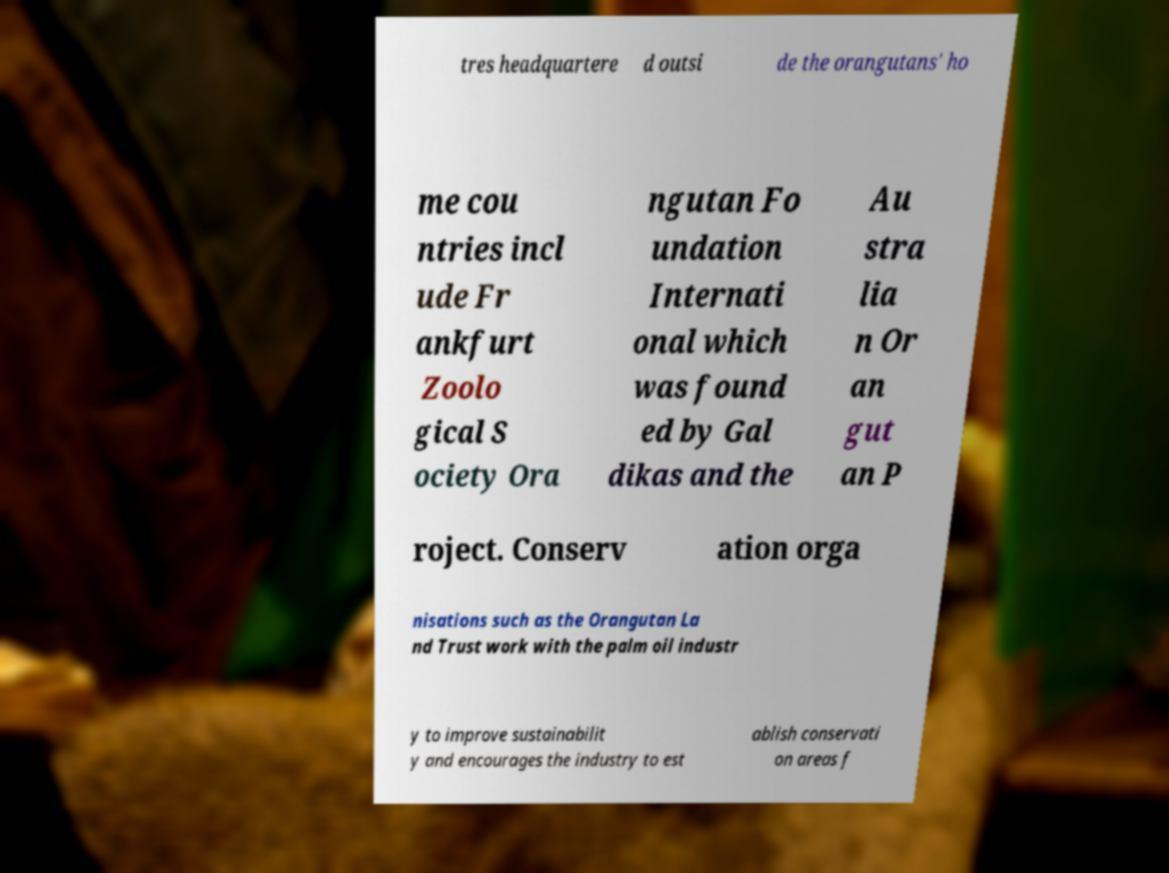Could you assist in decoding the text presented in this image and type it out clearly? tres headquartere d outsi de the orangutans' ho me cou ntries incl ude Fr ankfurt Zoolo gical S ociety Ora ngutan Fo undation Internati onal which was found ed by Gal dikas and the Au stra lia n Or an gut an P roject. Conserv ation orga nisations such as the Orangutan La nd Trust work with the palm oil industr y to improve sustainabilit y and encourages the industry to est ablish conservati on areas f 